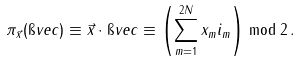<formula> <loc_0><loc_0><loc_500><loc_500>\pi _ { \vec { x } } ( \i v e c ) \equiv \vec { x } \cdot \i v e c \equiv \left ( \sum _ { m = 1 } ^ { 2 N } x _ { m } i _ { m } \right ) \bmod 2 \, .</formula> 